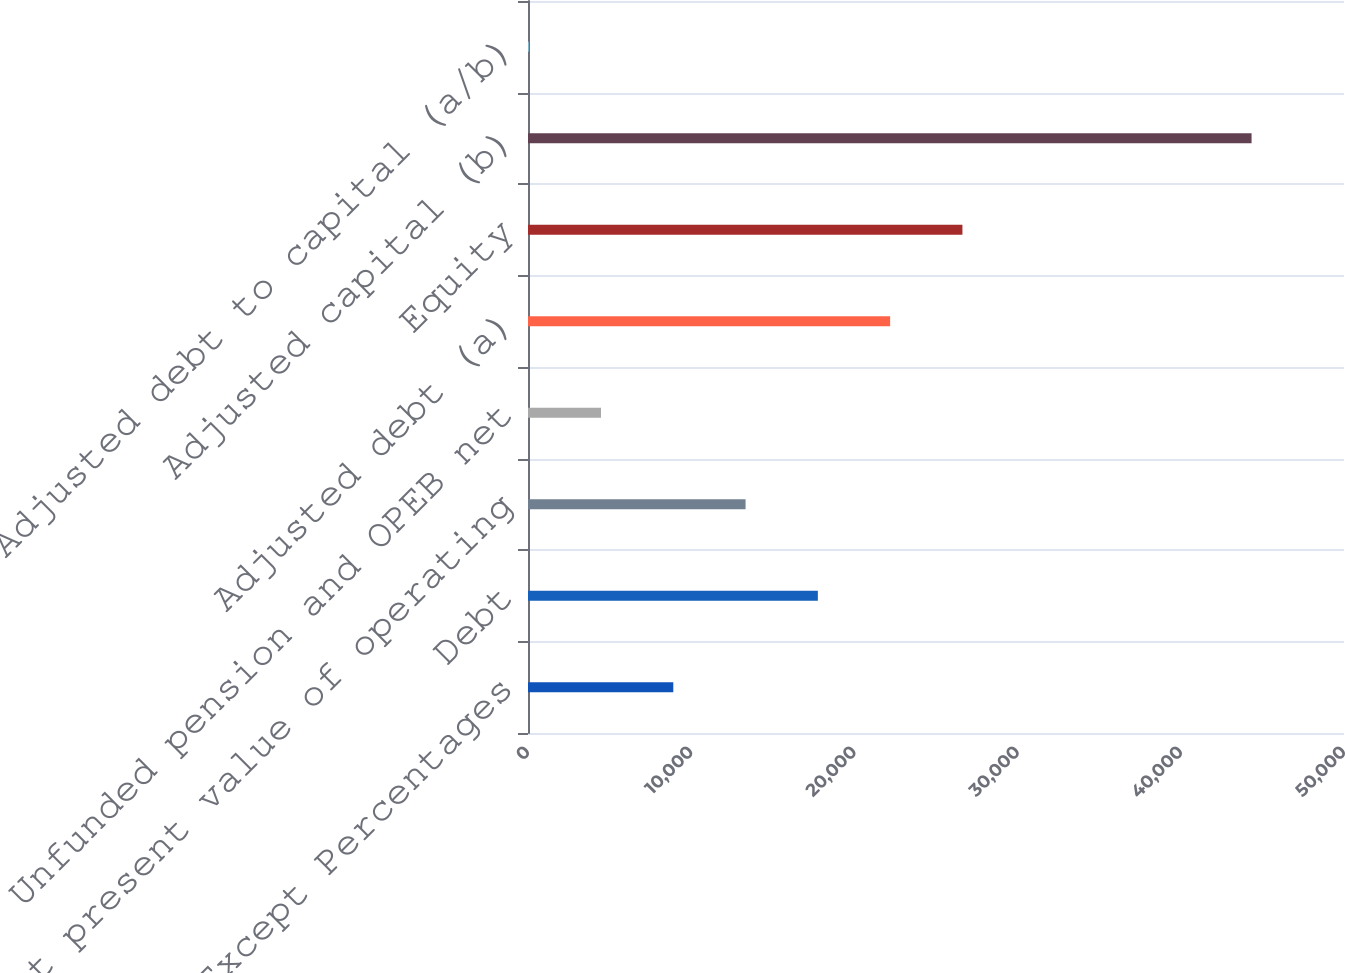<chart> <loc_0><loc_0><loc_500><loc_500><bar_chart><fcel>Millions Except Percentages<fcel>Debt<fcel>Net present value of operating<fcel>Unfunded pension and OPEB net<fcel>Adjusted debt (a)<fcel>Equity<fcel>Adjusted capital (b)<fcel>Adjusted debt to capital (a/b)<nl><fcel>8902.32<fcel>17760.7<fcel>13331.5<fcel>4473.11<fcel>22190<fcel>26619.2<fcel>44336<fcel>43.9<nl></chart> 